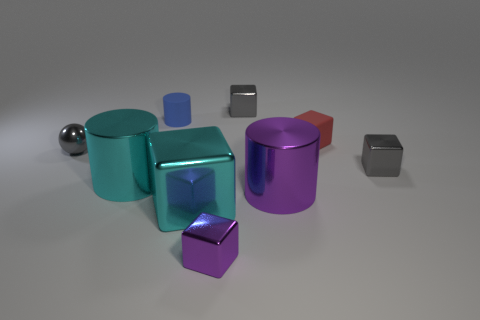Subtract all green cylinders. How many gray blocks are left? 2 Subtract all cyan cubes. How many cubes are left? 4 Subtract all small gray metallic cubes. How many cubes are left? 3 Subtract all cyan blocks. Subtract all red spheres. How many blocks are left? 4 Add 1 metallic objects. How many objects exist? 10 Subtract all blocks. How many objects are left? 4 Subtract 0 green cubes. How many objects are left? 9 Subtract all big purple things. Subtract all tiny red rubber things. How many objects are left? 7 Add 1 small blue cylinders. How many small blue cylinders are left? 2 Add 8 red rubber blocks. How many red rubber blocks exist? 9 